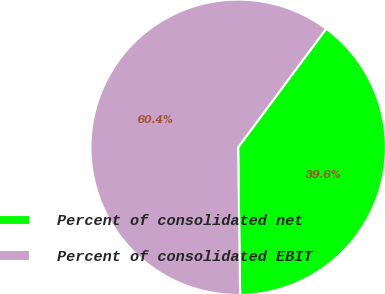<chart> <loc_0><loc_0><loc_500><loc_500><pie_chart><fcel>Percent of consolidated net<fcel>Percent of consolidated EBIT<nl><fcel>39.62%<fcel>60.38%<nl></chart> 